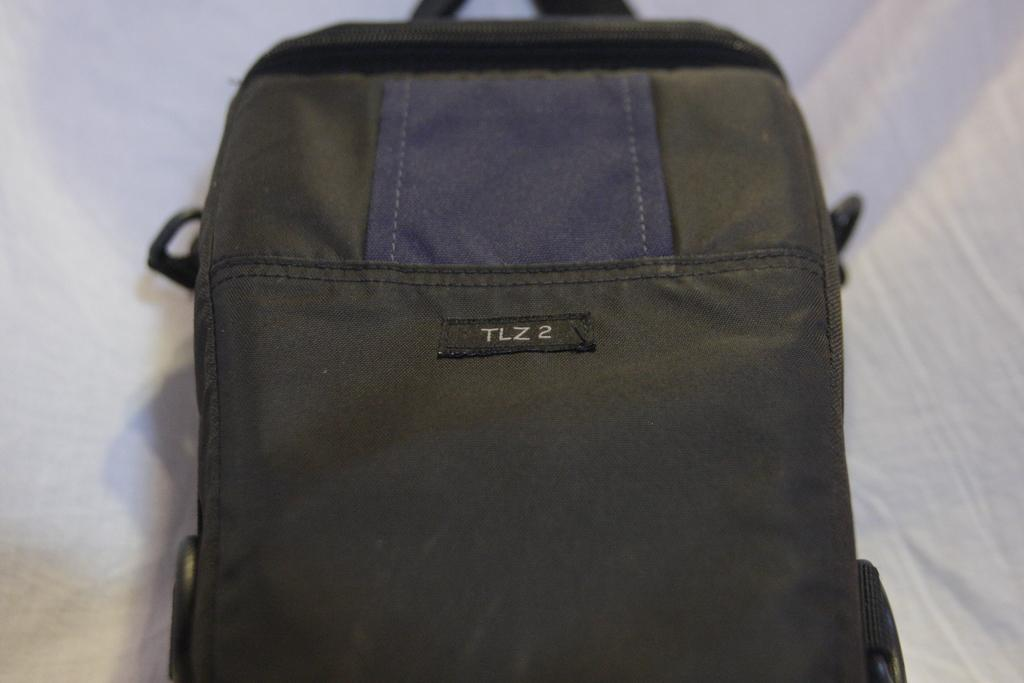What object is present in the image? There is a black bag in the image. What color is the background of the image? The background of the image is white. What verse is being recited by the governor in the image? There is no governor or verse present in the image; it only features a black bag against a white background. 